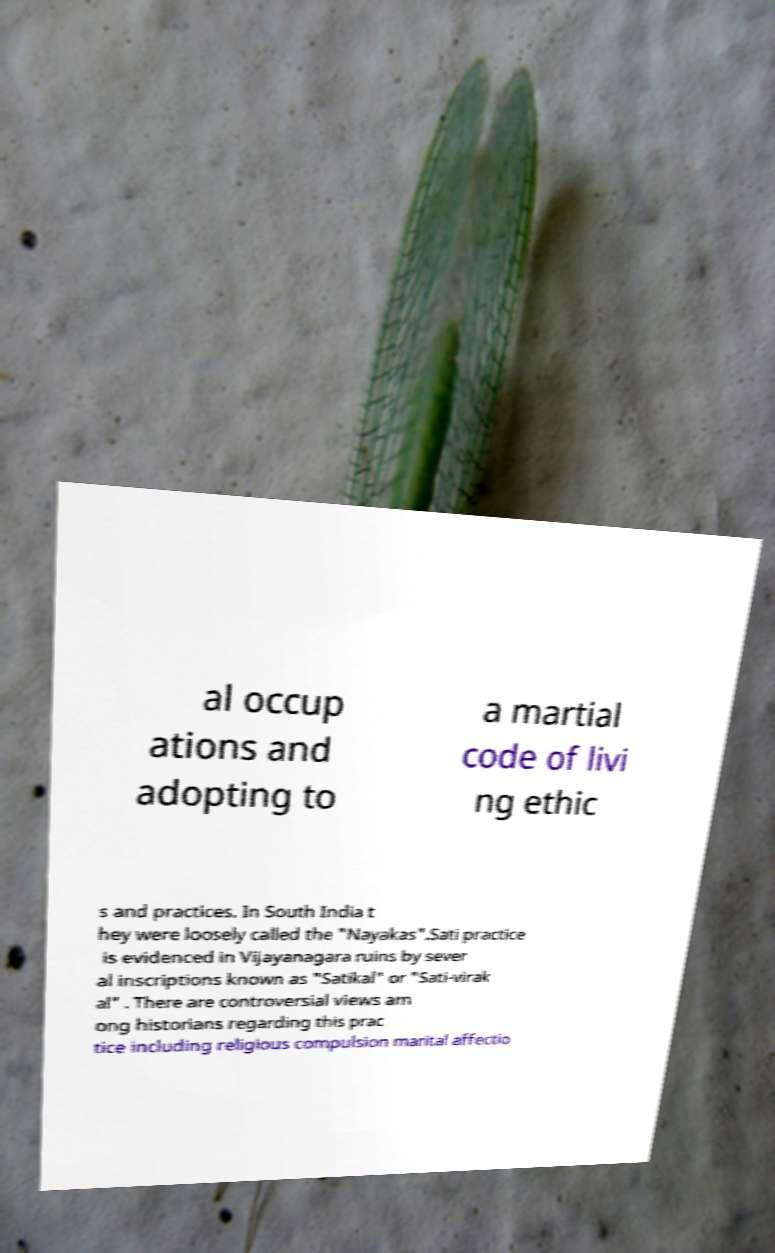Can you accurately transcribe the text from the provided image for me? al occup ations and adopting to a martial code of livi ng ethic s and practices. In South India t hey were loosely called the "Nayakas".Sati practice is evidenced in Vijayanagara ruins by sever al inscriptions known as "Satikal" or "Sati-virak al" . There are controversial views am ong historians regarding this prac tice including religious compulsion marital affectio 